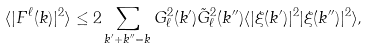<formula> <loc_0><loc_0><loc_500><loc_500>\langle | F ^ { \ell } ( k ) | ^ { 2 } \rangle \leq 2 \sum _ { k ^ { \prime } + k ^ { \prime \prime } = k } G _ { \ell } ^ { 2 } ( k ^ { \prime } ) \tilde { G } _ { \ell } ^ { 2 } ( k ^ { \prime \prime } ) \langle | \xi ( k ^ { \prime } ) | ^ { 2 } | \xi ( k ^ { \prime \prime } ) | ^ { 2 } \rangle ,</formula> 